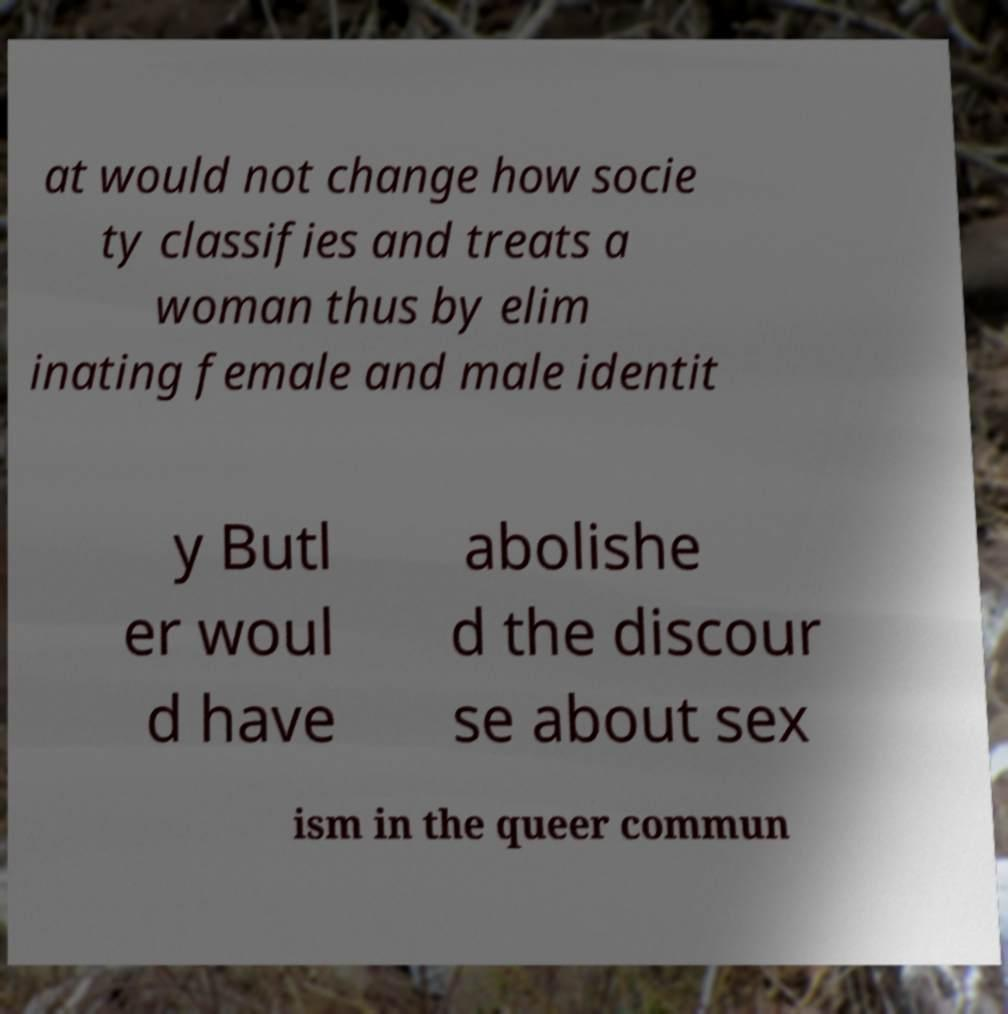There's text embedded in this image that I need extracted. Can you transcribe it verbatim? at would not change how socie ty classifies and treats a woman thus by elim inating female and male identit y Butl er woul d have abolishe d the discour se about sex ism in the queer commun 